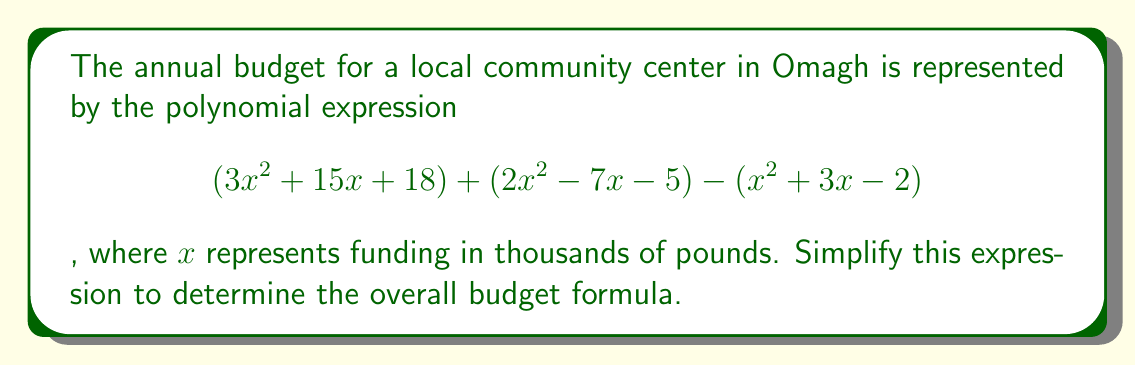Can you answer this question? To simplify this polynomial expression, we need to combine like terms:

1. Group the terms with $x^2$:
   $$(3x^2) + (2x^2) - (x^2) = 4x^2$$

2. Group the terms with $x$:
   $$(15x) + (-7x) - (3x) = 5x$$

3. Group the constant terms:
   $$(18) + (-5) - (-2) = 15$$

4. Combine the results from steps 1, 2, and 3:
   $$4x^2 + 5x + 15$$

This simplified expression represents the overall budget formula for the community center.
Answer: $$4x^2 + 5x + 15$$ 